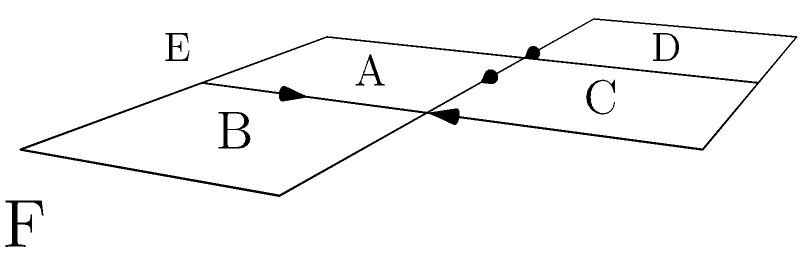As part of an early childhood education program, you're designing a spatial reasoning activity. The diagram shows an unfolded cube pattern. If the cube is folded along the lines, which face will be opposite to face A? To determine which face will be opposite to face A when the cube is folded, let's follow these steps:

1. Visualize the folding process:
   - Face B folds to the right of face A
   - Face C folds above face A
   - Face D folds to the left of face A
   - Face E folds below face A

2. Identify the remaining face:
   - Face F is the only face that doesn't share an edge with face A in the unfolded pattern

3. Understand the properties of a cube:
   - In a cube, opposite faces are those that don't share any edges
   - When folded, faces that are two steps away from each other in the unfolded pattern become opposite faces

4. Analyze the position of face F:
   - Face F is two steps away from face A in the unfolded pattern
   - It will fold to be on the opposite side of the cube from face A

Therefore, when the cube is folded, face F will be opposite to face A.

This spatial reasoning exercise helps develop children's ability to mentally manipulate 3D objects, an important skill for future learning in geometry, engineering, and problem-solving.
Answer: F 